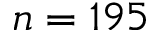Convert formula to latex. <formula><loc_0><loc_0><loc_500><loc_500>n = 1 9 5</formula> 